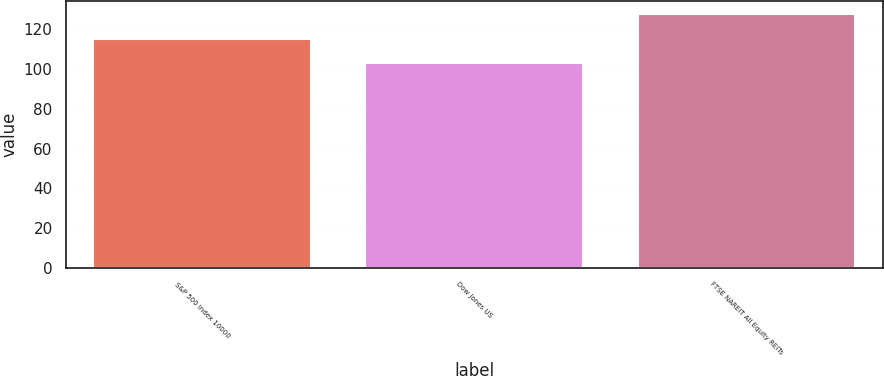<chart> <loc_0><loc_0><loc_500><loc_500><bar_chart><fcel>S&P 500 Index 10000<fcel>Dow Jones US<fcel>FTSE NAREIT All Equity REITs<nl><fcel>115.06<fcel>103.3<fcel>127.95<nl></chart> 